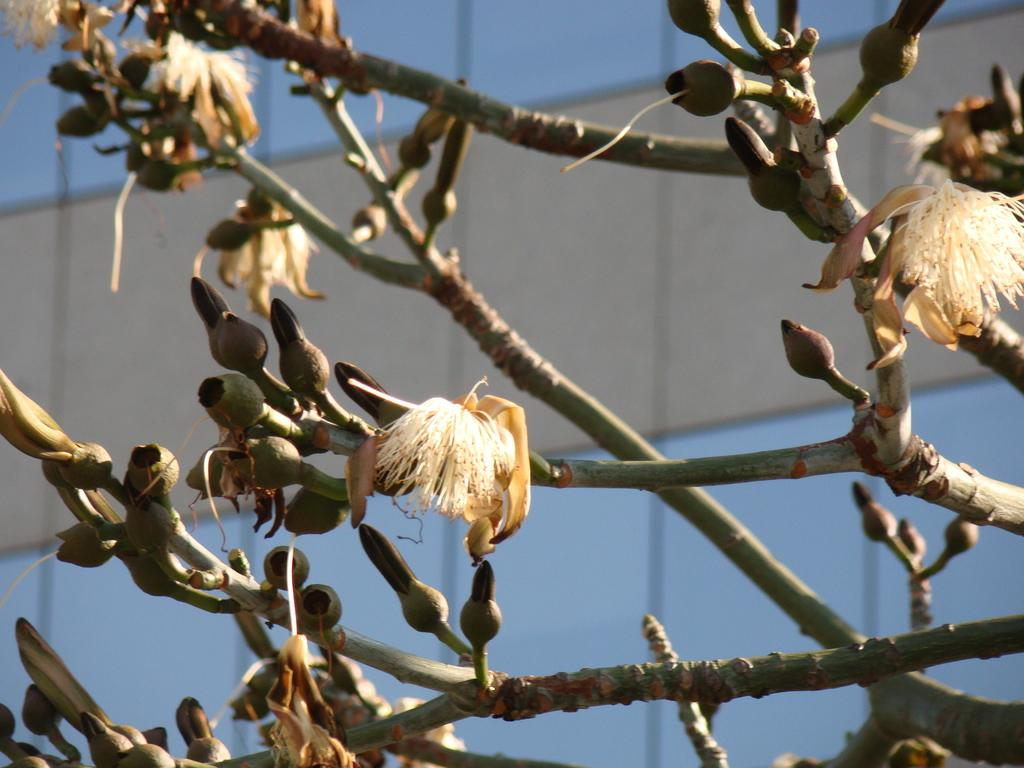What type of plant life is present in the image? There are flowers and buds of a plant in the image. Can you describe the background of the image? There is a blurred glass building in the background of the image. What type of arm is visible in the image? There is no arm present in the image; it features flowers, plant buds, and a blurred glass building in the background. 